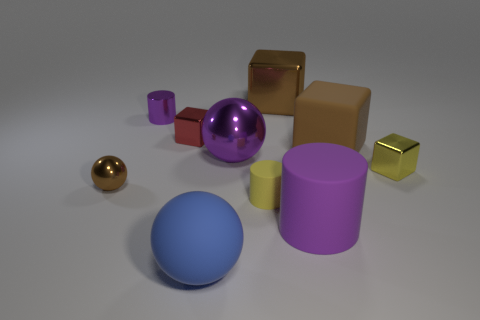Subtract all brown metallic spheres. How many spheres are left? 2 Subtract all yellow cylinders. How many cylinders are left? 2 Subtract all blue cylinders. How many brown blocks are left? 2 Subtract all balls. How many objects are left? 7 Subtract 2 purple cylinders. How many objects are left? 8 Subtract all green cubes. Subtract all gray cylinders. How many cubes are left? 4 Subtract all purple spheres. Subtract all brown objects. How many objects are left? 6 Add 6 shiny cubes. How many shiny cubes are left? 9 Add 3 big cyan metallic things. How many big cyan metallic things exist? 3 